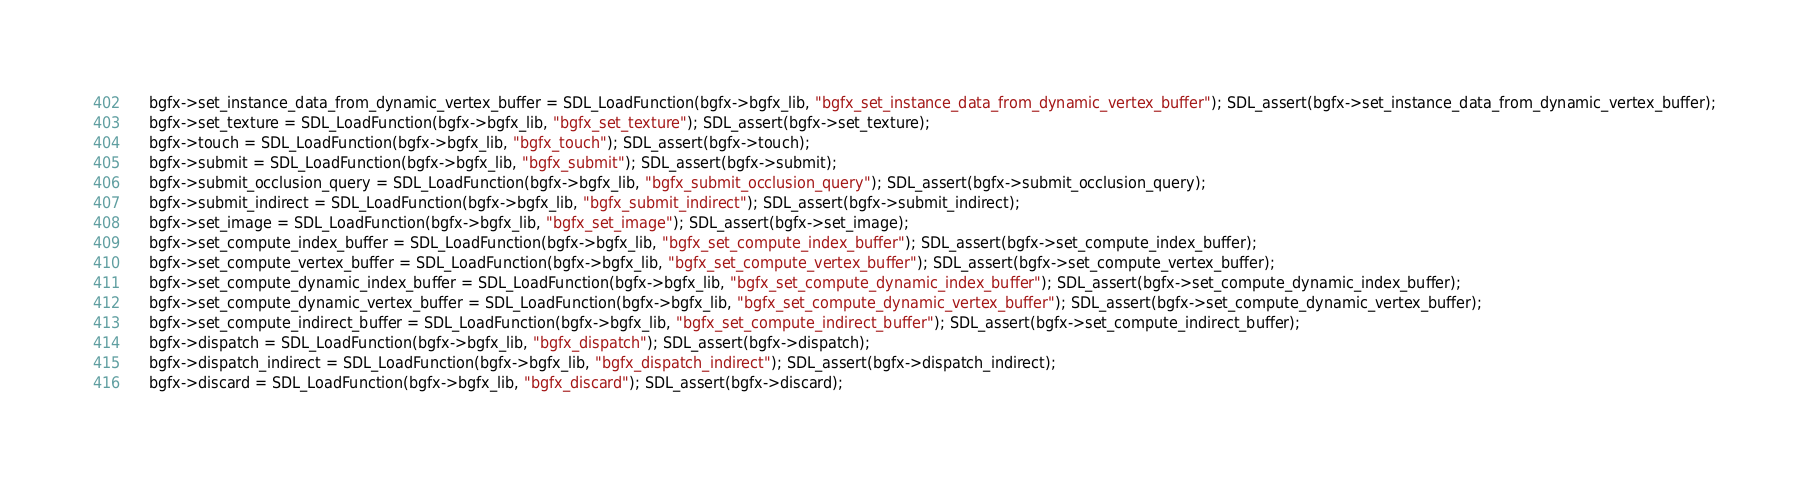Convert code to text. <code><loc_0><loc_0><loc_500><loc_500><_C_>    bgfx->set_instance_data_from_dynamic_vertex_buffer = SDL_LoadFunction(bgfx->bgfx_lib, "bgfx_set_instance_data_from_dynamic_vertex_buffer"); SDL_assert(bgfx->set_instance_data_from_dynamic_vertex_buffer);
    bgfx->set_texture = SDL_LoadFunction(bgfx->bgfx_lib, "bgfx_set_texture"); SDL_assert(bgfx->set_texture);
    bgfx->touch = SDL_LoadFunction(bgfx->bgfx_lib, "bgfx_touch"); SDL_assert(bgfx->touch);
    bgfx->submit = SDL_LoadFunction(bgfx->bgfx_lib, "bgfx_submit"); SDL_assert(bgfx->submit);
    bgfx->submit_occlusion_query = SDL_LoadFunction(bgfx->bgfx_lib, "bgfx_submit_occlusion_query"); SDL_assert(bgfx->submit_occlusion_query);
    bgfx->submit_indirect = SDL_LoadFunction(bgfx->bgfx_lib, "bgfx_submit_indirect"); SDL_assert(bgfx->submit_indirect);
    bgfx->set_image = SDL_LoadFunction(bgfx->bgfx_lib, "bgfx_set_image"); SDL_assert(bgfx->set_image);
    bgfx->set_compute_index_buffer = SDL_LoadFunction(bgfx->bgfx_lib, "bgfx_set_compute_index_buffer"); SDL_assert(bgfx->set_compute_index_buffer);
    bgfx->set_compute_vertex_buffer = SDL_LoadFunction(bgfx->bgfx_lib, "bgfx_set_compute_vertex_buffer"); SDL_assert(bgfx->set_compute_vertex_buffer);
    bgfx->set_compute_dynamic_index_buffer = SDL_LoadFunction(bgfx->bgfx_lib, "bgfx_set_compute_dynamic_index_buffer"); SDL_assert(bgfx->set_compute_dynamic_index_buffer);
    bgfx->set_compute_dynamic_vertex_buffer = SDL_LoadFunction(bgfx->bgfx_lib, "bgfx_set_compute_dynamic_vertex_buffer"); SDL_assert(bgfx->set_compute_dynamic_vertex_buffer);
    bgfx->set_compute_indirect_buffer = SDL_LoadFunction(bgfx->bgfx_lib, "bgfx_set_compute_indirect_buffer"); SDL_assert(bgfx->set_compute_indirect_buffer);
    bgfx->dispatch = SDL_LoadFunction(bgfx->bgfx_lib, "bgfx_dispatch"); SDL_assert(bgfx->dispatch);
    bgfx->dispatch_indirect = SDL_LoadFunction(bgfx->bgfx_lib, "bgfx_dispatch_indirect"); SDL_assert(bgfx->dispatch_indirect);
    bgfx->discard = SDL_LoadFunction(bgfx->bgfx_lib, "bgfx_discard"); SDL_assert(bgfx->discard);</code> 